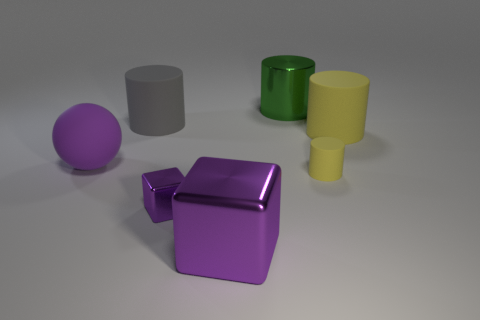Add 1 tiny gray matte balls. How many objects exist? 8 Subtract all blocks. How many objects are left? 5 Subtract all gray balls. Subtract all large rubber things. How many objects are left? 4 Add 4 big purple blocks. How many big purple blocks are left? 5 Add 5 big brown shiny spheres. How many big brown shiny spheres exist? 5 Subtract 1 purple spheres. How many objects are left? 6 